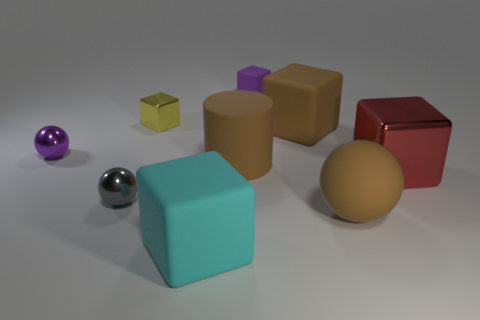The metallic cube to the left of the big cyan rubber cube is what color?
Offer a terse response. Yellow. Are there any large brown cylinders that are to the left of the big brown matte object that is in front of the gray shiny sphere?
Your answer should be very brief. Yes. Does the big red shiny thing have the same shape as the small metallic object that is in front of the big cylinder?
Offer a very short reply. No. How big is the rubber thing that is both left of the matte ball and in front of the gray shiny object?
Ensure brevity in your answer.  Large. Are there any large red objects that have the same material as the small yellow object?
Your answer should be very brief. Yes. What size is the rubber ball that is the same color as the matte cylinder?
Your answer should be very brief. Large. The purple object left of the small purple thing that is behind the yellow object is made of what material?
Your answer should be compact. Metal. What number of things have the same color as the big matte sphere?
Give a very brief answer. 2. There is a red cube that is made of the same material as the yellow cube; what size is it?
Keep it short and to the point. Large. There is a large brown rubber object on the right side of the brown matte block; what is its shape?
Your answer should be very brief. Sphere. 